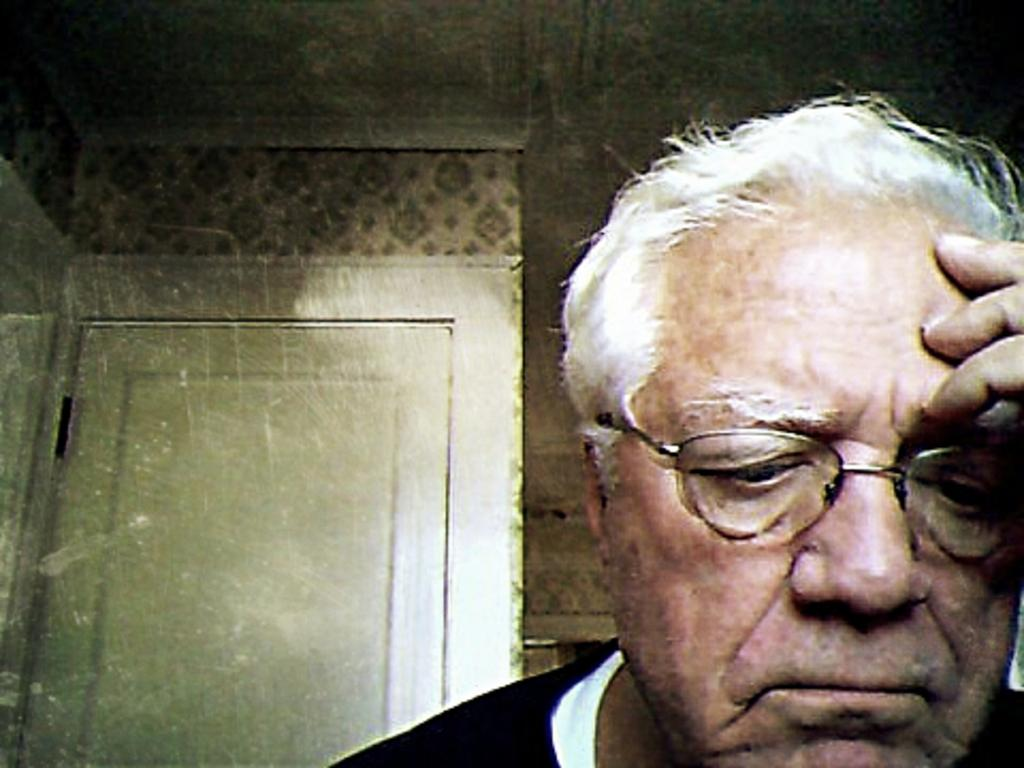Who is present in the image? There is a man in the image. What can be observed about the man's appearance? The man is wearing spectacles. What is visible in the background of the image? There is a white color door in the background of the image. What type of dinner is being served at the zoo in the image? There is no dinner or zoo present in the image; it features a man wearing spectacles and a white color door in the background. 